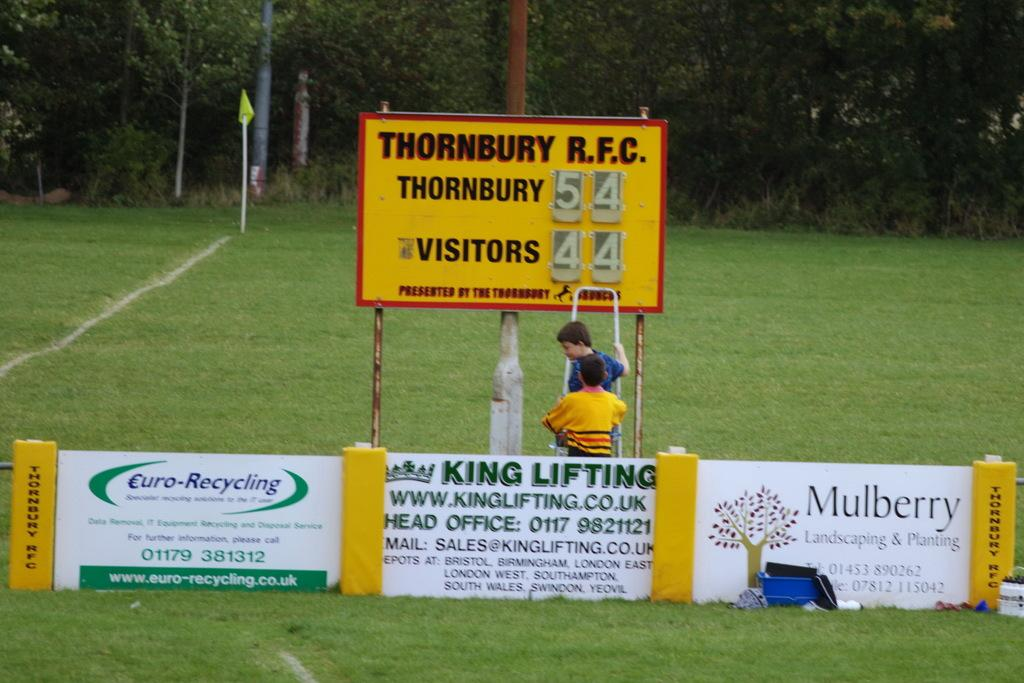<image>
Share a concise interpretation of the image provided. A yellow sign with a kid standing in front of it that says thornbury. 